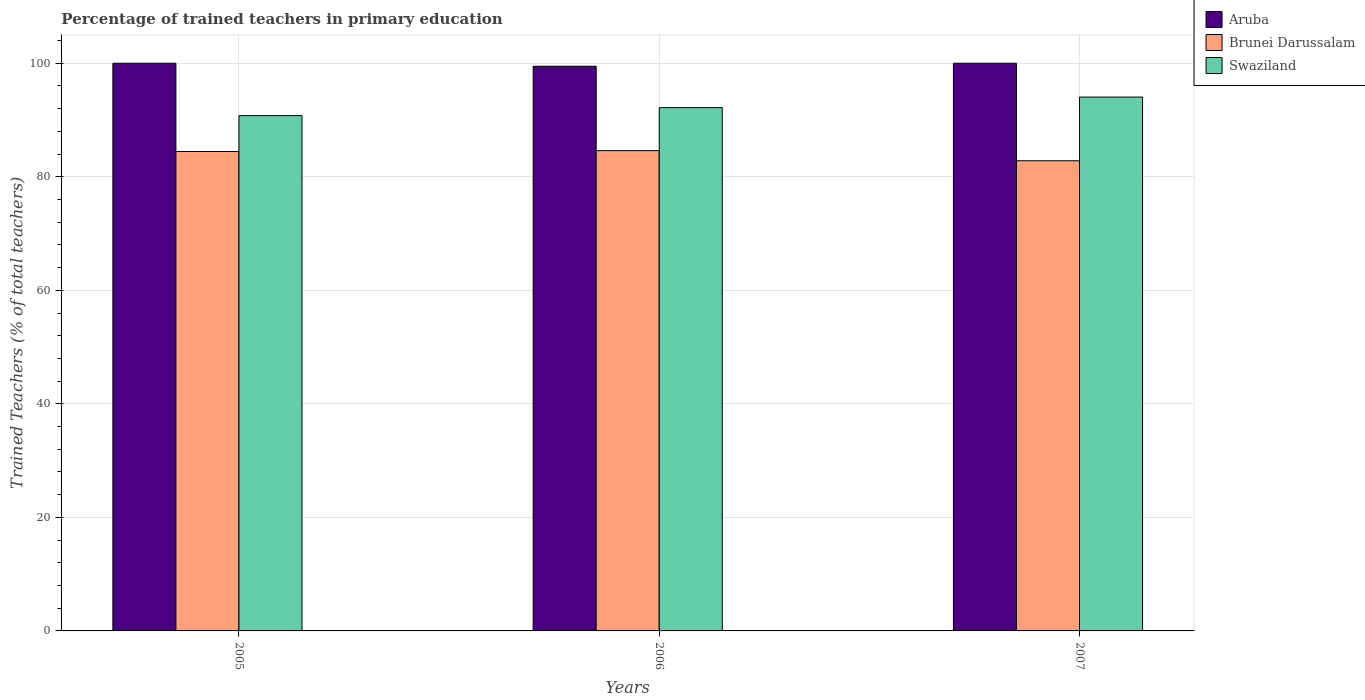How many different coloured bars are there?
Offer a terse response. 3. How many groups of bars are there?
Your answer should be compact. 3. Are the number of bars per tick equal to the number of legend labels?
Your answer should be compact. Yes. How many bars are there on the 3rd tick from the left?
Give a very brief answer. 3. In how many cases, is the number of bars for a given year not equal to the number of legend labels?
Your response must be concise. 0. What is the percentage of trained teachers in Brunei Darussalam in 2005?
Your answer should be compact. 84.45. Across all years, what is the minimum percentage of trained teachers in Brunei Darussalam?
Your answer should be compact. 82.83. In which year was the percentage of trained teachers in Swaziland minimum?
Keep it short and to the point. 2005. What is the total percentage of trained teachers in Brunei Darussalam in the graph?
Ensure brevity in your answer.  251.89. What is the difference between the percentage of trained teachers in Swaziland in 2005 and that in 2007?
Provide a short and direct response. -3.27. What is the difference between the percentage of trained teachers in Swaziland in 2005 and the percentage of trained teachers in Brunei Darussalam in 2006?
Provide a succinct answer. 6.17. What is the average percentage of trained teachers in Swaziland per year?
Your response must be concise. 92.33. In the year 2006, what is the difference between the percentage of trained teachers in Brunei Darussalam and percentage of trained teachers in Swaziland?
Make the answer very short. -7.58. What is the ratio of the percentage of trained teachers in Brunei Darussalam in 2005 to that in 2006?
Make the answer very short. 1. Is the difference between the percentage of trained teachers in Brunei Darussalam in 2005 and 2006 greater than the difference between the percentage of trained teachers in Swaziland in 2005 and 2006?
Give a very brief answer. Yes. What is the difference between the highest and the second highest percentage of trained teachers in Brunei Darussalam?
Your answer should be compact. 0.15. What is the difference between the highest and the lowest percentage of trained teachers in Aruba?
Give a very brief answer. 0.52. In how many years, is the percentage of trained teachers in Brunei Darussalam greater than the average percentage of trained teachers in Brunei Darussalam taken over all years?
Give a very brief answer. 2. Is the sum of the percentage of trained teachers in Swaziland in 2005 and 2007 greater than the maximum percentage of trained teachers in Brunei Darussalam across all years?
Give a very brief answer. Yes. What does the 3rd bar from the left in 2006 represents?
Provide a succinct answer. Swaziland. What does the 2nd bar from the right in 2006 represents?
Offer a very short reply. Brunei Darussalam. Are the values on the major ticks of Y-axis written in scientific E-notation?
Give a very brief answer. No. Where does the legend appear in the graph?
Your answer should be compact. Top right. How many legend labels are there?
Offer a terse response. 3. How are the legend labels stacked?
Make the answer very short. Vertical. What is the title of the graph?
Provide a short and direct response. Percentage of trained teachers in primary education. What is the label or title of the X-axis?
Your answer should be compact. Years. What is the label or title of the Y-axis?
Ensure brevity in your answer.  Trained Teachers (% of total teachers). What is the Trained Teachers (% of total teachers) in Aruba in 2005?
Ensure brevity in your answer.  100. What is the Trained Teachers (% of total teachers) in Brunei Darussalam in 2005?
Your response must be concise. 84.45. What is the Trained Teachers (% of total teachers) of Swaziland in 2005?
Provide a short and direct response. 90.77. What is the Trained Teachers (% of total teachers) in Aruba in 2006?
Offer a very short reply. 99.48. What is the Trained Teachers (% of total teachers) in Brunei Darussalam in 2006?
Provide a short and direct response. 84.6. What is the Trained Teachers (% of total teachers) in Swaziland in 2006?
Offer a terse response. 92.18. What is the Trained Teachers (% of total teachers) of Aruba in 2007?
Your answer should be compact. 100. What is the Trained Teachers (% of total teachers) of Brunei Darussalam in 2007?
Provide a short and direct response. 82.83. What is the Trained Teachers (% of total teachers) in Swaziland in 2007?
Provide a short and direct response. 94.04. Across all years, what is the maximum Trained Teachers (% of total teachers) in Aruba?
Your response must be concise. 100. Across all years, what is the maximum Trained Teachers (% of total teachers) of Brunei Darussalam?
Ensure brevity in your answer.  84.6. Across all years, what is the maximum Trained Teachers (% of total teachers) in Swaziland?
Your answer should be compact. 94.04. Across all years, what is the minimum Trained Teachers (% of total teachers) of Aruba?
Make the answer very short. 99.48. Across all years, what is the minimum Trained Teachers (% of total teachers) of Brunei Darussalam?
Make the answer very short. 82.83. Across all years, what is the minimum Trained Teachers (% of total teachers) in Swaziland?
Offer a very short reply. 90.77. What is the total Trained Teachers (% of total teachers) of Aruba in the graph?
Provide a succinct answer. 299.48. What is the total Trained Teachers (% of total teachers) in Brunei Darussalam in the graph?
Your answer should be very brief. 251.89. What is the total Trained Teachers (% of total teachers) of Swaziland in the graph?
Make the answer very short. 277. What is the difference between the Trained Teachers (% of total teachers) of Aruba in 2005 and that in 2006?
Your response must be concise. 0.52. What is the difference between the Trained Teachers (% of total teachers) of Brunei Darussalam in 2005 and that in 2006?
Keep it short and to the point. -0.15. What is the difference between the Trained Teachers (% of total teachers) in Swaziland in 2005 and that in 2006?
Make the answer very short. -1.41. What is the difference between the Trained Teachers (% of total teachers) of Brunei Darussalam in 2005 and that in 2007?
Your response must be concise. 1.63. What is the difference between the Trained Teachers (% of total teachers) in Swaziland in 2005 and that in 2007?
Offer a very short reply. -3.27. What is the difference between the Trained Teachers (% of total teachers) in Aruba in 2006 and that in 2007?
Offer a very short reply. -0.52. What is the difference between the Trained Teachers (% of total teachers) of Brunei Darussalam in 2006 and that in 2007?
Your answer should be compact. 1.78. What is the difference between the Trained Teachers (% of total teachers) of Swaziland in 2006 and that in 2007?
Offer a terse response. -1.86. What is the difference between the Trained Teachers (% of total teachers) of Aruba in 2005 and the Trained Teachers (% of total teachers) of Brunei Darussalam in 2006?
Offer a very short reply. 15.4. What is the difference between the Trained Teachers (% of total teachers) in Aruba in 2005 and the Trained Teachers (% of total teachers) in Swaziland in 2006?
Provide a short and direct response. 7.82. What is the difference between the Trained Teachers (% of total teachers) in Brunei Darussalam in 2005 and the Trained Teachers (% of total teachers) in Swaziland in 2006?
Your answer should be very brief. -7.73. What is the difference between the Trained Teachers (% of total teachers) of Aruba in 2005 and the Trained Teachers (% of total teachers) of Brunei Darussalam in 2007?
Provide a short and direct response. 17.17. What is the difference between the Trained Teachers (% of total teachers) in Aruba in 2005 and the Trained Teachers (% of total teachers) in Swaziland in 2007?
Make the answer very short. 5.96. What is the difference between the Trained Teachers (% of total teachers) of Brunei Darussalam in 2005 and the Trained Teachers (% of total teachers) of Swaziland in 2007?
Offer a terse response. -9.59. What is the difference between the Trained Teachers (% of total teachers) of Aruba in 2006 and the Trained Teachers (% of total teachers) of Brunei Darussalam in 2007?
Keep it short and to the point. 16.65. What is the difference between the Trained Teachers (% of total teachers) of Aruba in 2006 and the Trained Teachers (% of total teachers) of Swaziland in 2007?
Make the answer very short. 5.43. What is the difference between the Trained Teachers (% of total teachers) of Brunei Darussalam in 2006 and the Trained Teachers (% of total teachers) of Swaziland in 2007?
Offer a terse response. -9.44. What is the average Trained Teachers (% of total teachers) in Aruba per year?
Your response must be concise. 99.83. What is the average Trained Teachers (% of total teachers) in Brunei Darussalam per year?
Provide a short and direct response. 83.96. What is the average Trained Teachers (% of total teachers) in Swaziland per year?
Provide a short and direct response. 92.33. In the year 2005, what is the difference between the Trained Teachers (% of total teachers) of Aruba and Trained Teachers (% of total teachers) of Brunei Darussalam?
Offer a very short reply. 15.55. In the year 2005, what is the difference between the Trained Teachers (% of total teachers) of Aruba and Trained Teachers (% of total teachers) of Swaziland?
Offer a very short reply. 9.23. In the year 2005, what is the difference between the Trained Teachers (% of total teachers) in Brunei Darussalam and Trained Teachers (% of total teachers) in Swaziland?
Offer a very short reply. -6.32. In the year 2006, what is the difference between the Trained Teachers (% of total teachers) in Aruba and Trained Teachers (% of total teachers) in Brunei Darussalam?
Ensure brevity in your answer.  14.87. In the year 2006, what is the difference between the Trained Teachers (% of total teachers) of Aruba and Trained Teachers (% of total teachers) of Swaziland?
Keep it short and to the point. 7.29. In the year 2006, what is the difference between the Trained Teachers (% of total teachers) of Brunei Darussalam and Trained Teachers (% of total teachers) of Swaziland?
Your response must be concise. -7.58. In the year 2007, what is the difference between the Trained Teachers (% of total teachers) of Aruba and Trained Teachers (% of total teachers) of Brunei Darussalam?
Your answer should be very brief. 17.17. In the year 2007, what is the difference between the Trained Teachers (% of total teachers) of Aruba and Trained Teachers (% of total teachers) of Swaziland?
Keep it short and to the point. 5.96. In the year 2007, what is the difference between the Trained Teachers (% of total teachers) in Brunei Darussalam and Trained Teachers (% of total teachers) in Swaziland?
Give a very brief answer. -11.22. What is the ratio of the Trained Teachers (% of total teachers) of Aruba in 2005 to that in 2006?
Provide a succinct answer. 1.01. What is the ratio of the Trained Teachers (% of total teachers) in Swaziland in 2005 to that in 2006?
Make the answer very short. 0.98. What is the ratio of the Trained Teachers (% of total teachers) in Brunei Darussalam in 2005 to that in 2007?
Make the answer very short. 1.02. What is the ratio of the Trained Teachers (% of total teachers) in Swaziland in 2005 to that in 2007?
Provide a short and direct response. 0.97. What is the ratio of the Trained Teachers (% of total teachers) in Brunei Darussalam in 2006 to that in 2007?
Offer a terse response. 1.02. What is the ratio of the Trained Teachers (% of total teachers) of Swaziland in 2006 to that in 2007?
Make the answer very short. 0.98. What is the difference between the highest and the second highest Trained Teachers (% of total teachers) in Aruba?
Provide a succinct answer. 0. What is the difference between the highest and the second highest Trained Teachers (% of total teachers) of Brunei Darussalam?
Provide a succinct answer. 0.15. What is the difference between the highest and the second highest Trained Teachers (% of total teachers) of Swaziland?
Your answer should be very brief. 1.86. What is the difference between the highest and the lowest Trained Teachers (% of total teachers) in Aruba?
Your answer should be compact. 0.52. What is the difference between the highest and the lowest Trained Teachers (% of total teachers) of Brunei Darussalam?
Your answer should be very brief. 1.78. What is the difference between the highest and the lowest Trained Teachers (% of total teachers) of Swaziland?
Your answer should be compact. 3.27. 